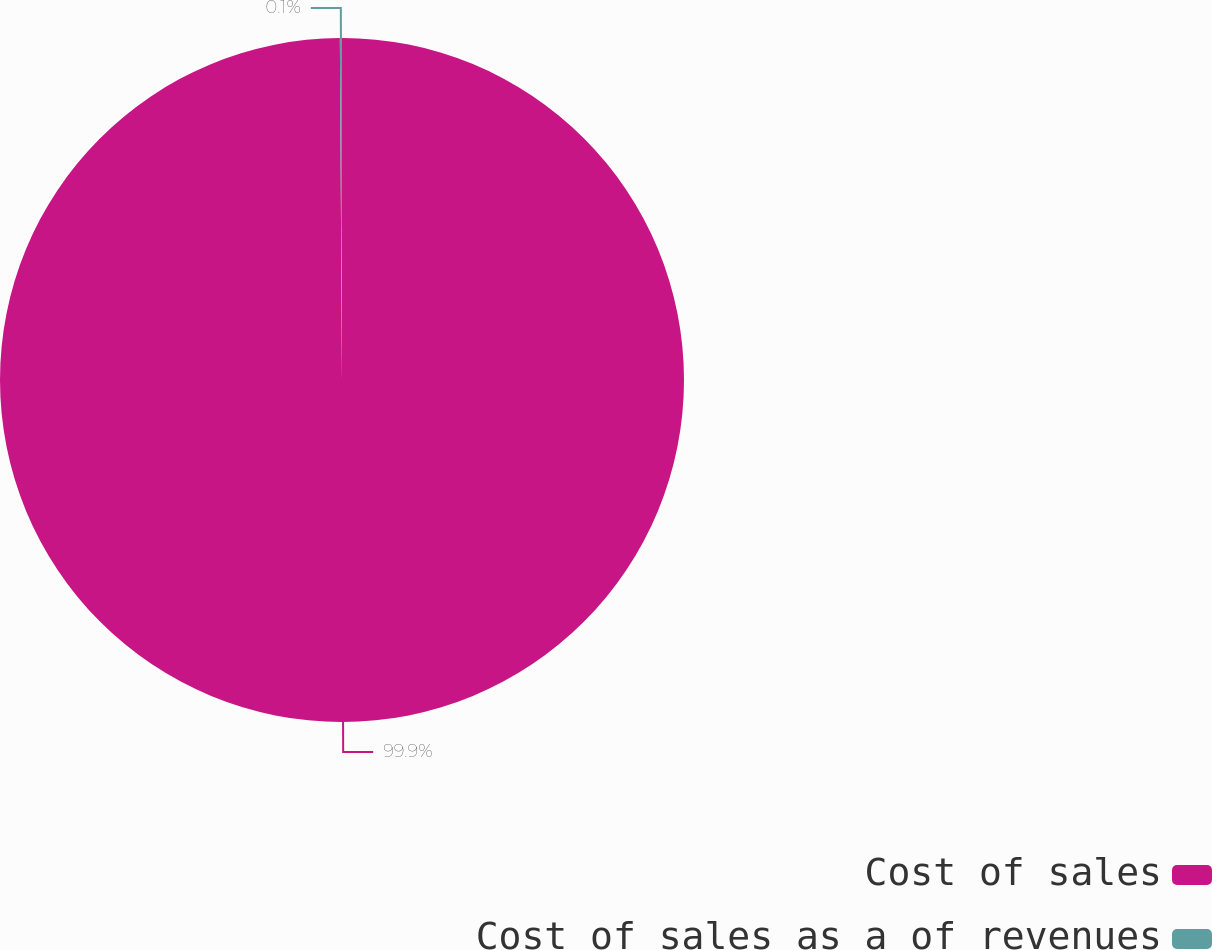<chart> <loc_0><loc_0><loc_500><loc_500><pie_chart><fcel>Cost of sales<fcel>Cost of sales as a of revenues<nl><fcel>99.9%<fcel>0.1%<nl></chart> 